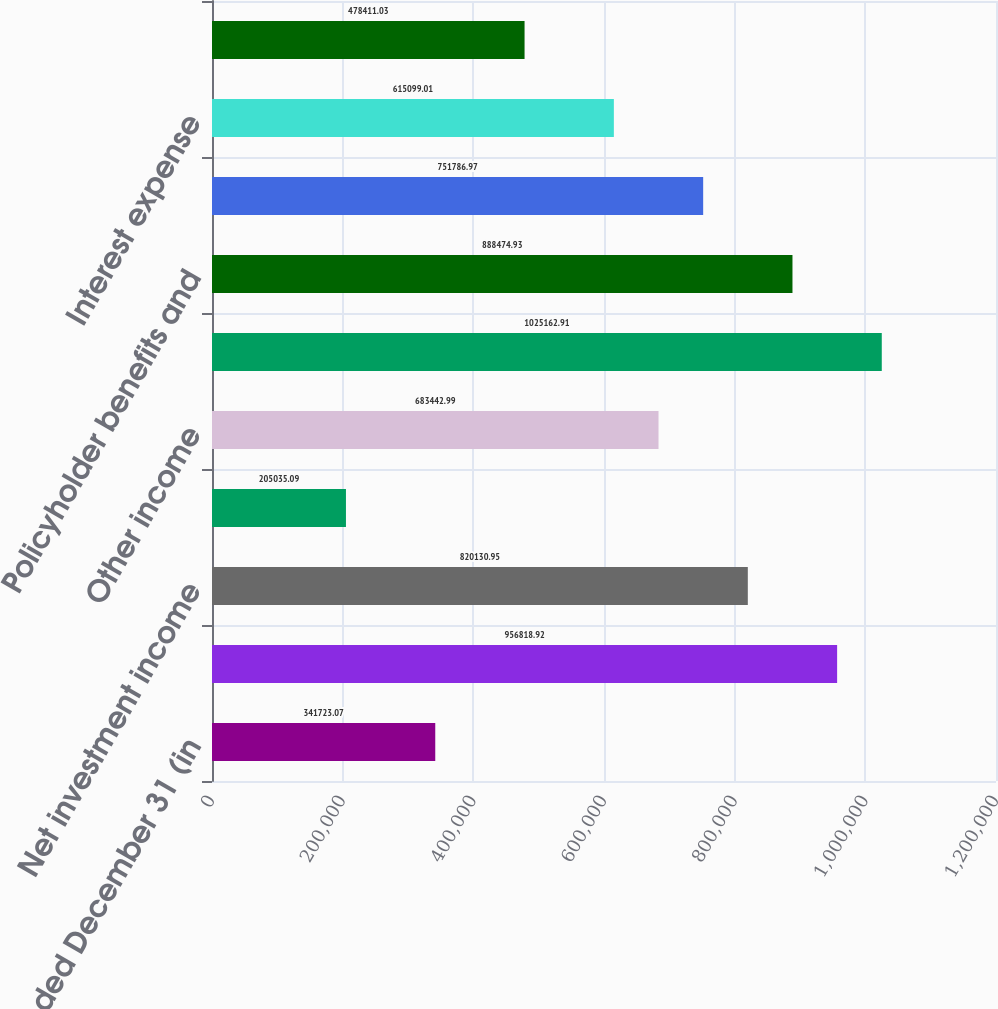Convert chart to OTSL. <chart><loc_0><loc_0><loc_500><loc_500><bar_chart><fcel>Years Ended December 31 (in<fcel>Premiums and other<fcel>Net investment income<fcel>Net realized capital losses<fcel>Other income<fcel>Total revenues<fcel>Policyholder benefits and<fcel>Policy acquisition and other<fcel>Interest expense<fcel>Other expenses<nl><fcel>341723<fcel>956819<fcel>820131<fcel>205035<fcel>683443<fcel>1.02516e+06<fcel>888475<fcel>751787<fcel>615099<fcel>478411<nl></chart> 